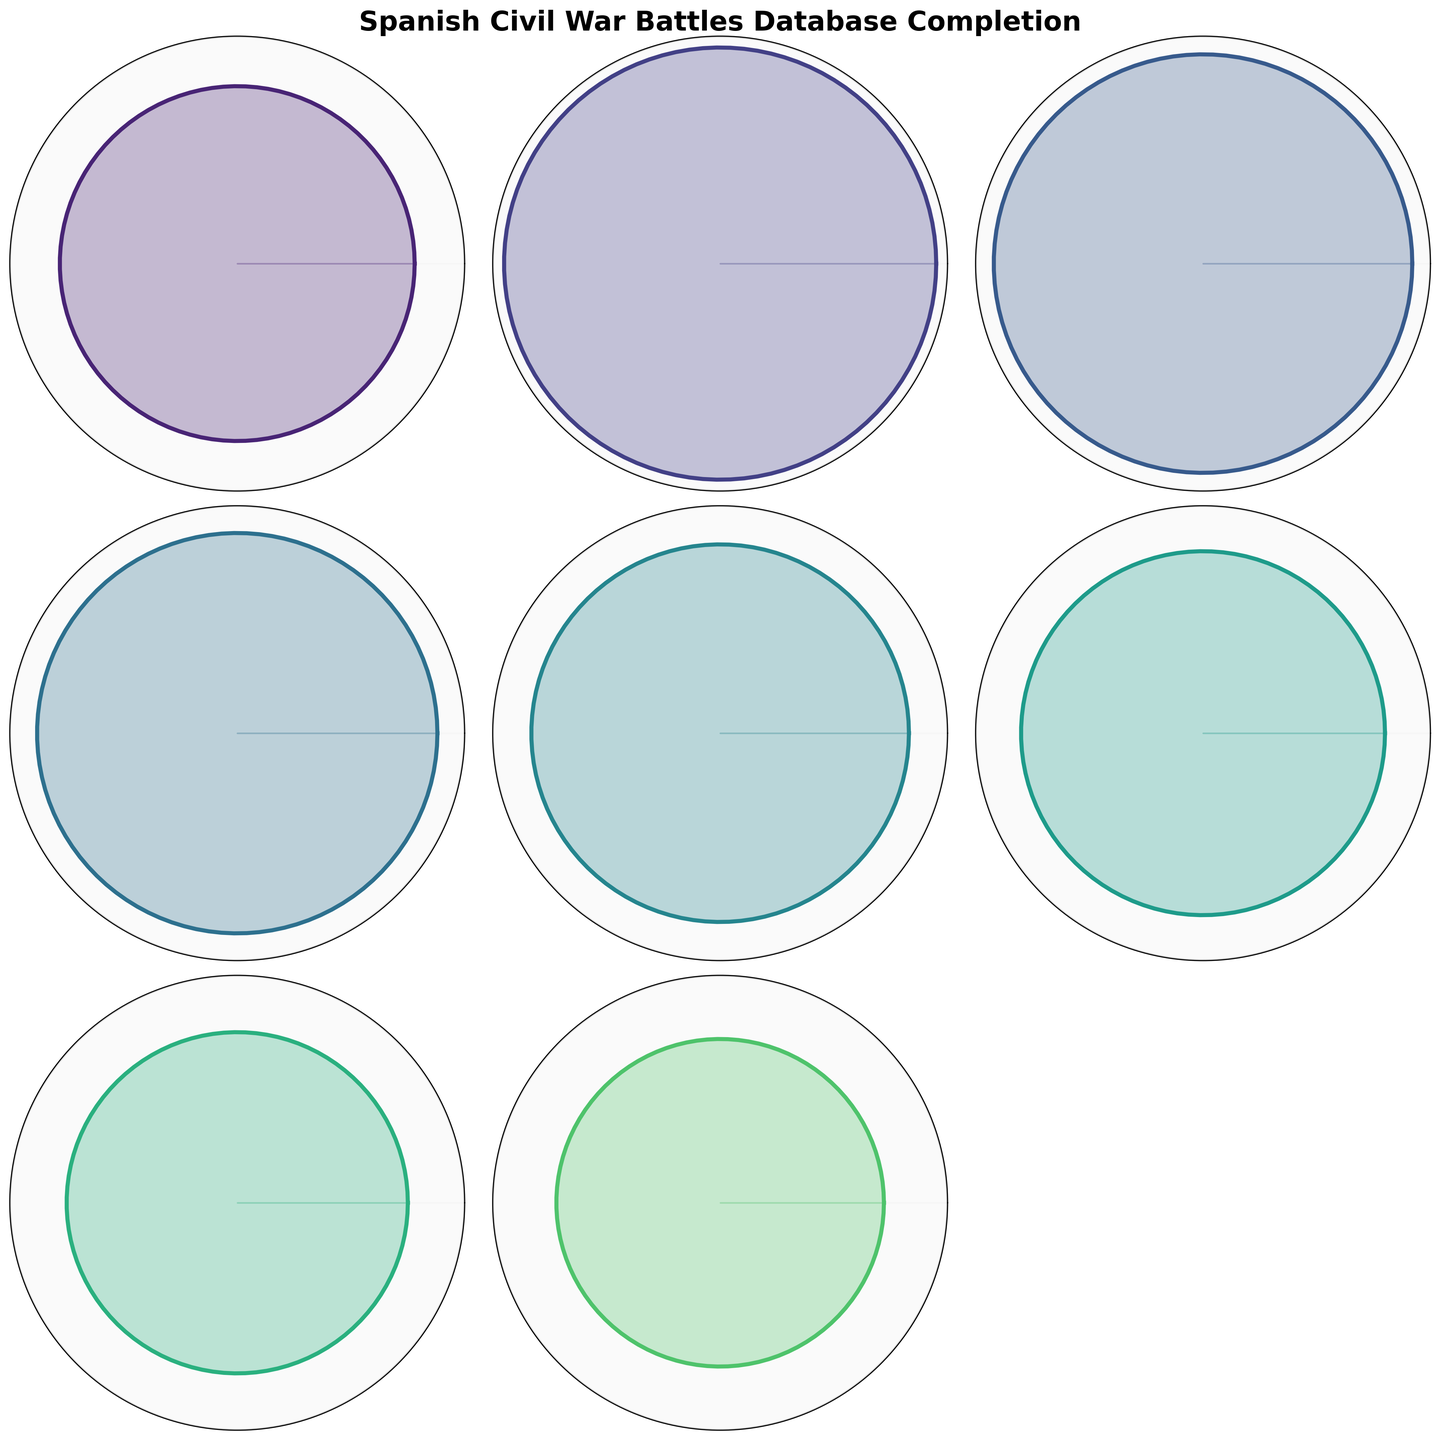What is the overall completion percentage of the database? The figure shows a gauge for the "Overall Database Completion" category. The pointer indicates 78%.
Answer: 78% Which battle has the highest completion percentage? Looking for the highest value in the gauge charts, "Battle of Madrid" has a completion percentage of 95%.
Answer: Battle of Madrid Which battles have a completion percentage greater than or equal to 80%? The battles "Battle of Madrid", "Battle of the Ebro", "Siege of Alcázar", "Battle of Guadalajara", and "Battle of Teruel" all have completion percentages of 80% or higher.
Answer: Battle of Madrid, Battle of the Ebro, Siege of Alcázar, Battle of Guadalajara, Battle of Teruel What is the difference in completion rates between the Battle of Madrid and the Bombing of Guernica? The completion rate for the Battle of Madrid is 95% and for the Bombing of Guernica is 70%. The difference is 95% - 70% = 25%.
Answer: 25% What is the mean completion percentage of battles listed in the chart? Add up all the completion percentages of each battle: 95 + 92 + 88 + 83 + 80 + 75 + 72 + 70 + 65 = 720. Then divide by the number of battles (9). The mean is 720 / 9 = 80%.
Answer: 80% Which battle has the lowest completion percentage? By locating the smallest value in the gauge charts, "Battle of Belchite" has the lowest completion percentage of 65%.
Answer: Battle of Belchite Compare the completion percentages of the Battle of Guadalajara and the Battle of Teruel. Which one is higher and by how much? The completion rate for the Battle of Guadalajara is 83%, and for the Battle of Teruel, it is 80%. Guadalajara's completion rate is higher by 83% - 80% = 3%.
Answer: Battle of Guadalajara, 3% How many battles have a completion percentage of less than 80%? Battles with less than 80% completion percentage are "Battle of Brunete", "Battle of Jarama", "Bombing of Guernica", and "Battle of Belchite". There are 4 such battles.
Answer: 4 